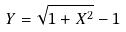Convert formula to latex. <formula><loc_0><loc_0><loc_500><loc_500>Y = \sqrt { 1 + X ^ { 2 } } - 1</formula> 